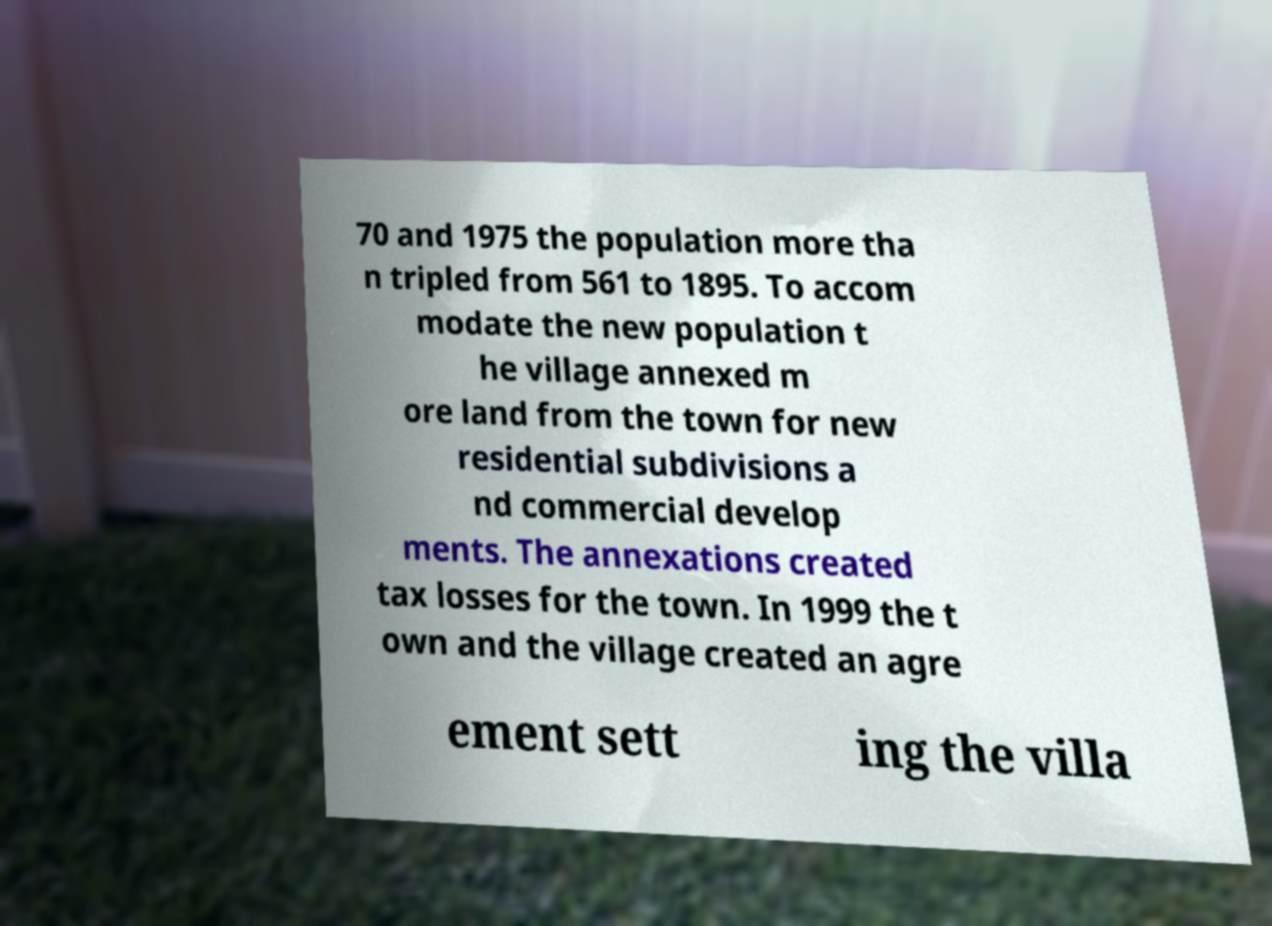Please identify and transcribe the text found in this image. 70 and 1975 the population more tha n tripled from 561 to 1895. To accom modate the new population t he village annexed m ore land from the town for new residential subdivisions a nd commercial develop ments. The annexations created tax losses for the town. In 1999 the t own and the village created an agre ement sett ing the villa 